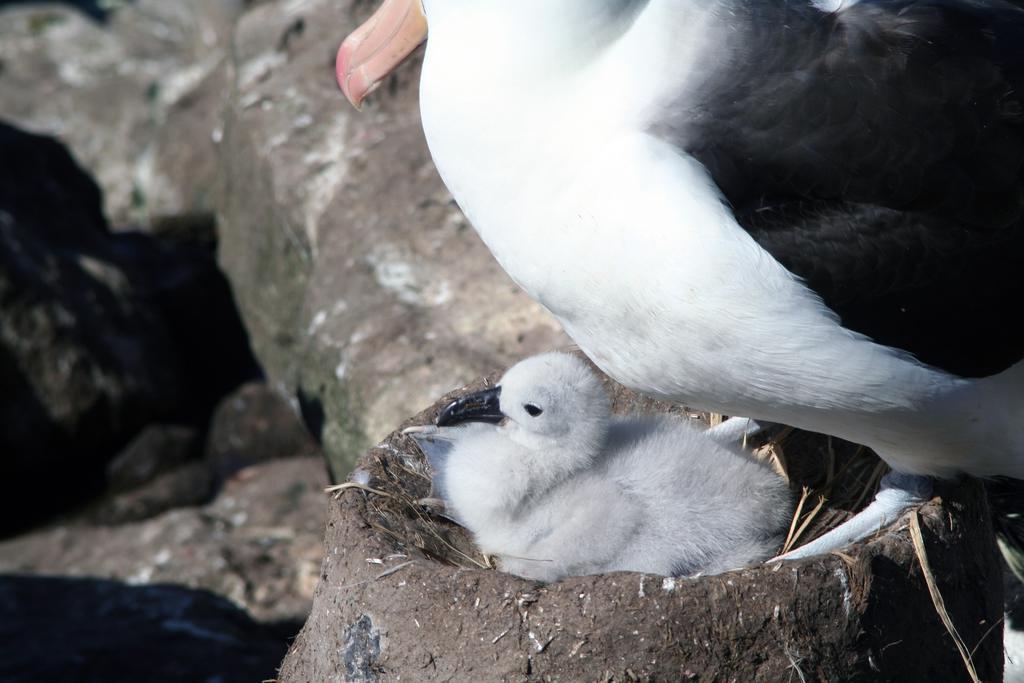Can you describe this image briefly? In this picture we can see two birds on nest. In the background of the image it is blurry. 